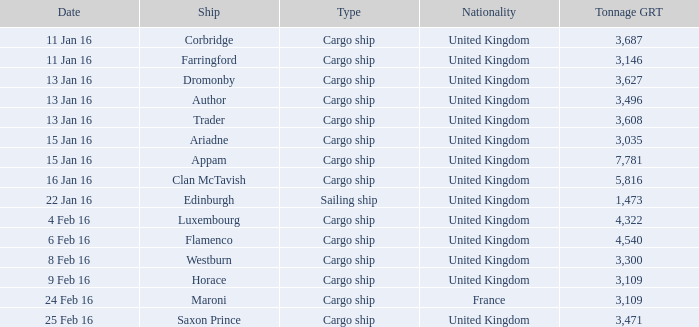What is the nationality of the ship appam? United Kingdom. 